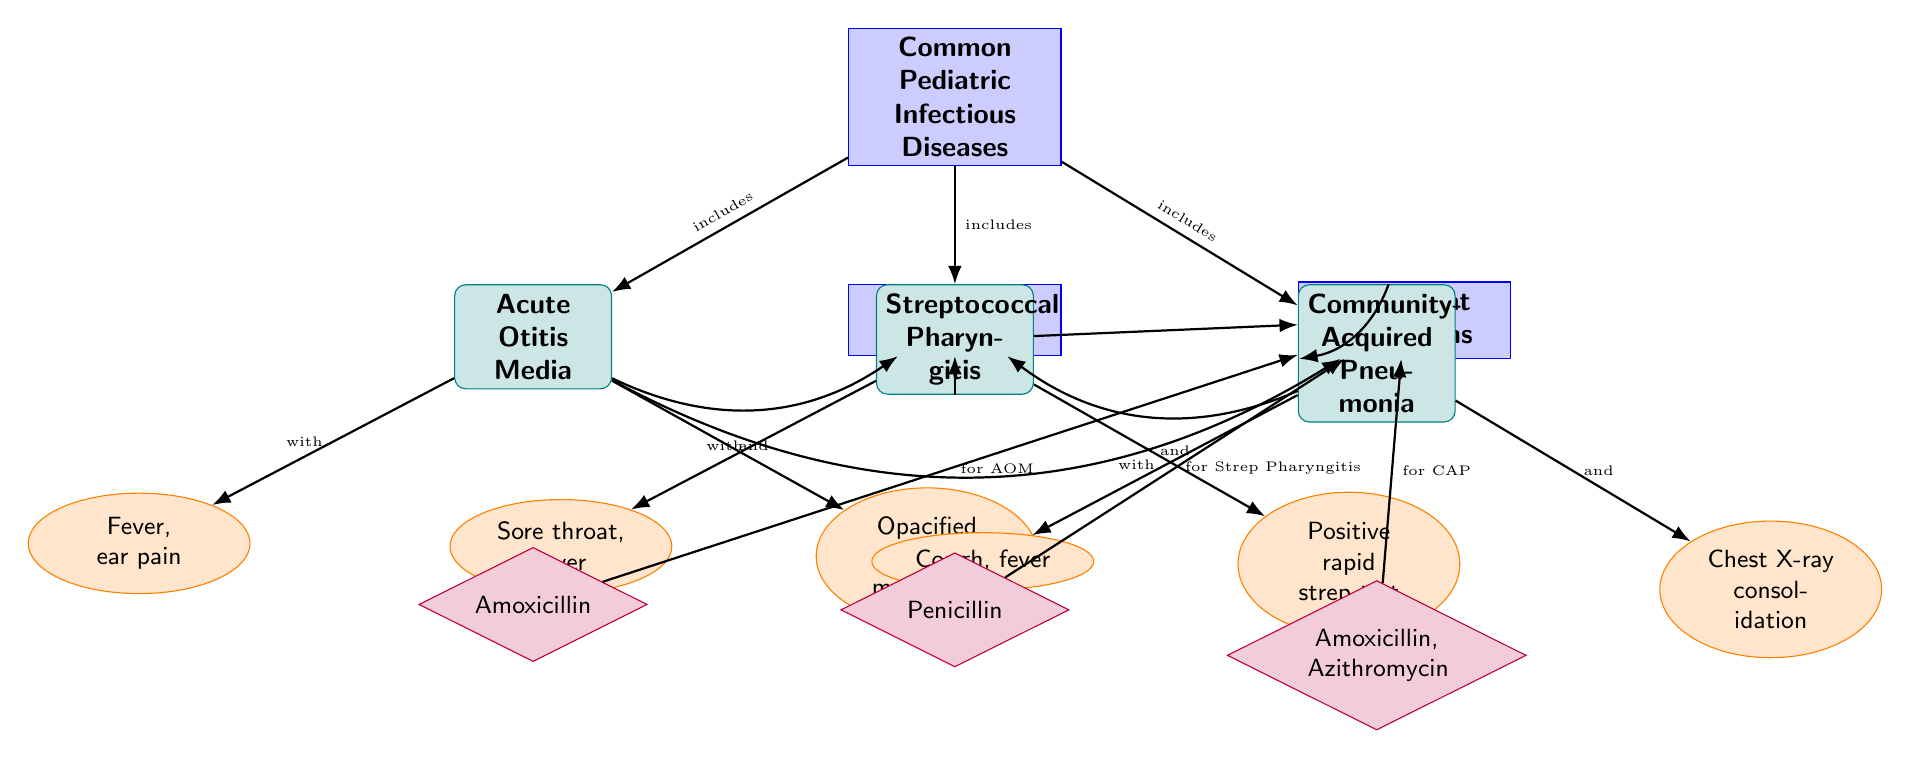What are the three common pediatric infectious diseases listed? The diagram includes three diseases under the category "Common Pediatric Infectious Diseases" which are Acute Otitis Media, Streptococcal Pharyngitis, and Community-Acquired Pneumonia.
Answer: Acute Otitis Media, Streptococcal Pharyngitis, Community-Acquired Pneumonia What symptom is associated with Acute Otitis Media? In the diagram, Acute Otitis Media is associated with two symptoms: fever and ear pain. The question asked for one symptom, which is fever.
Answer: Fever What is the treatment algorithm for Streptococcal Pharyngitis? The diagram shows that the treatment for Streptococcal Pharyngitis is Penicillin, which is mentioned under the treatment algorithms section linked to that disease.
Answer: Penicillin How many symptoms are listed for Community-Acquired Pneumonia? The diagram indicates two symptoms are associated with Community-Acquired Pneumonia: cough and fever.
Answer: Two Which symptoms are associated with Acute Otitis Media according to the diagram? The symptoms for Acute Otitis Media are specifically listed in the diagram as fever and opacified tympanic membrane. Therefore, both symptoms must be noted for a complete answer.
Answer: Fever, opacified tympanic membrane What treatment is prescribed for Acute Otitis Media? In the treatment section linked to Acute Otitis Media, the diagram states that Amoxicillin is the prescribed treatment. This directly answers the question by identifying the medication.
Answer: Amoxicillin Which disease is associated with a positive rapid strep test? The diagram clearly indicates that the symptom associated with Streptococcal Pharyngitis includes having a positive rapid strep test, as shown under that disease category.
Answer: Streptococcal Pharyngitis What presentation does Community-Acquired Pneumonia have on a chest X-ray? The diagram specifies that Community-Acquired Pneumonia can show consolidation on a chest X-ray, described under the symptoms for that disease.
Answer: Consolidation 